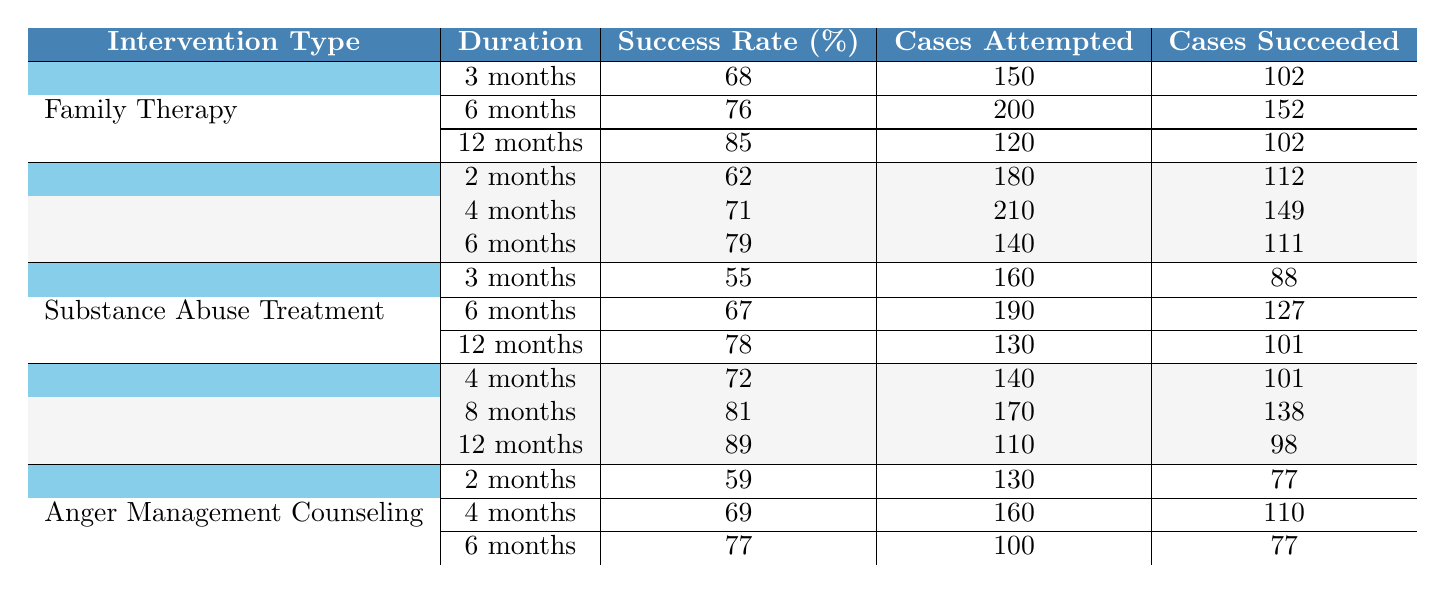What is the success rate of Family Therapy after 12 months? The table shows that under Family Therapy, for the 12-month duration, the success rate is listed as 85%.
Answer: 85% How many cases were attempted in the Parenting Classes for a duration of 4 months? The table indicates that for Parenting Classes over 4 months, there were 210 cases attempted.
Answer: 210 What is the average success rate for Substance Abuse Treatment across all durations? For Substance Abuse Treatment, the success rates are 55%, 67%, and 78%. The average is (55 + 67 + 78) / 3 = 200 / 3 = 66.67%, rounded to two decimal places.
Answer: 66.67% Was the success rate for Home Visitation Program greater than 80% at any duration? Looking at Home Visitation Program, the success rates are 72%, 81%, and 89%. Since the 8-month and 12-month durations both exceed 80%, the answer is yes.
Answer: Yes Which intervention type had the highest success rate after 6 months? After 6 months, the success rates for the different interventions are Family Therapy (76%), Parenting Classes (79%), Substance Abuse Treatment (67%), Home Visitation Program (81%), and Anger Management Counseling (77%). The highest value is from the Home Visitation Program with 81%.
Answer: Home Visitation Program What is the difference in success rates between 3-month Family Therapy and 3-month Substance Abuse Treatment? For Family Therapy at 3 months, the success rate is 68%, while for Substance Abuse Treatment it is 55%. The difference is 68% - 55% = 13%.
Answer: 13% How many cases succeeded in the Parenting Classes for 6 months? The table states that for Parenting Classes with a duration of 6 months, 111 cases succeeded.
Answer: 111 What is the total number of cases attempted across all durations for the Anger Management Counseling intervention? The table shows cases attempted at 2 months (130), 4 months (160), and 6 months (100). Total cases attempted is 130 + 160 + 100 = 390.
Answer: 390 Which intervention type had the lowest success rate overall? The success rates for all intervention types are 68%, 76%, 85% for Family Therapy; 62%, 71%, 79% for Parenting Classes; 55%, 67%, 78% for Substance Abuse Treatment; 72%, 81%, 89% for Home Visitation; and 59%, 69%, 77% for Anger Management. The lowest average belongs to Substance Abuse Treatment with an average of 66.67%.
Answer: Substance Abuse Treatment How many total cases succeeded in Home Visitation Program over 12 months? The table indicates that for the Home Visitation Program at 12 months, 98 cases succeeded.
Answer: 98 Is it true that all durations of Parenting Classes had a success rate higher than 70%? Checking the Parenting Classes durations: 62% for 2 months, 71% for 4 months, and 79% for 6 months. The 2-month case does not exceed 70%, so the statement is false.
Answer: No 